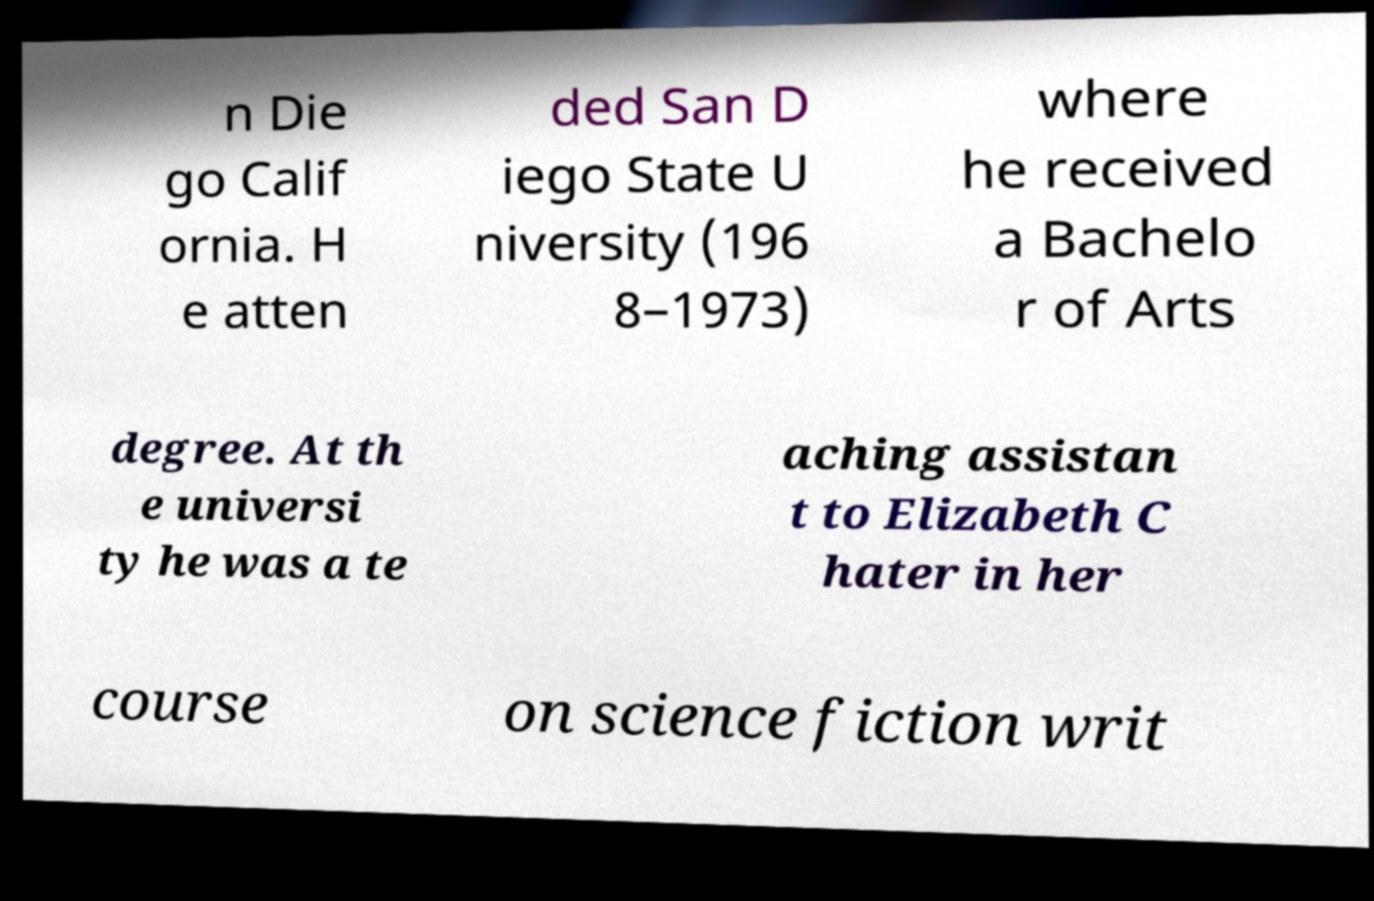Could you assist in decoding the text presented in this image and type it out clearly? n Die go Calif ornia. H e atten ded San D iego State U niversity (196 8–1973) where he received a Bachelo r of Arts degree. At th e universi ty he was a te aching assistan t to Elizabeth C hater in her course on science fiction writ 